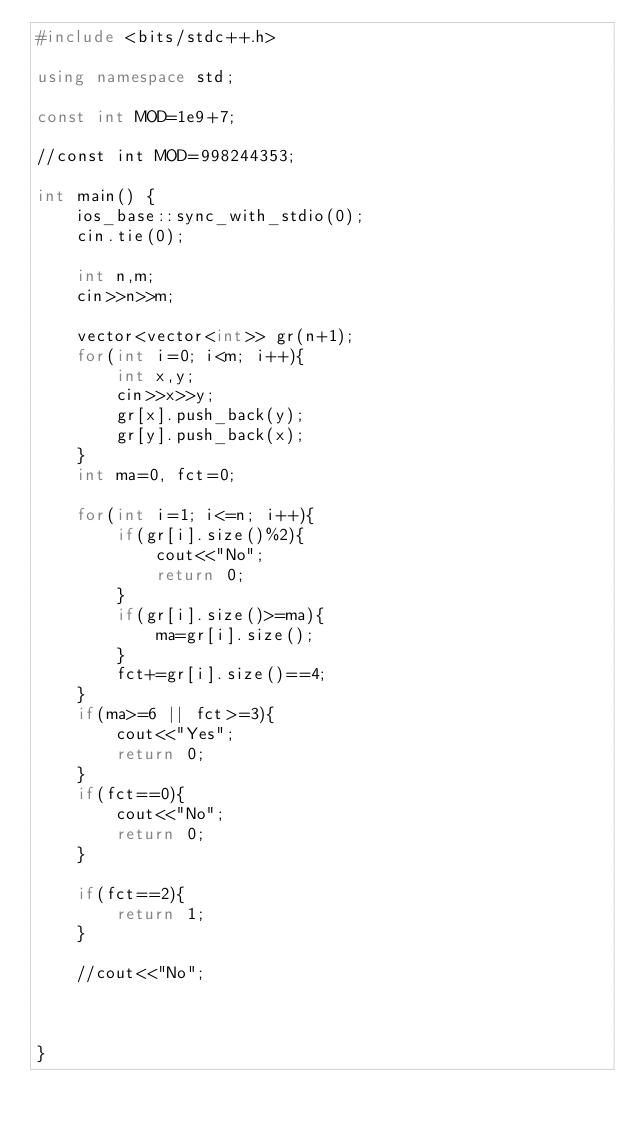<code> <loc_0><loc_0><loc_500><loc_500><_C++_>#include <bits/stdc++.h>

using namespace std;

const int MOD=1e9+7;

//const int MOD=998244353;

int main() {
    ios_base::sync_with_stdio(0);
    cin.tie(0);
    
    int n,m;
    cin>>n>>m;
    
    vector<vector<int>> gr(n+1);
    for(int i=0; i<m; i++){
        int x,y;
        cin>>x>>y;
        gr[x].push_back(y);
        gr[y].push_back(x);
    }
    int ma=0, fct=0;
    
    for(int i=1; i<=n; i++){
        if(gr[i].size()%2){
            cout<<"No";
            return 0;
        }
        if(gr[i].size()>=ma){
            ma=gr[i].size();
        }
        fct+=gr[i].size()==4;
    }
    if(ma>=6 || fct>=3){
        cout<<"Yes";
        return 0;
    }
    if(fct==0){
        cout<<"No";
        return 0;
    }
    
    if(fct==2){
        return 1;
    }
    
    //cout<<"No";
    
    
    
}</code> 